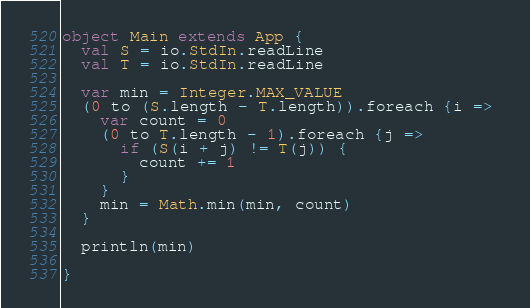Convert code to text. <code><loc_0><loc_0><loc_500><loc_500><_Scala_>
object Main extends App {
  val S = io.StdIn.readLine
  val T = io.StdIn.readLine

  var min = Integer.MAX_VALUE
  (0 to (S.length - T.length)).foreach {i => 
    var count = 0
    (0 to T.length - 1).foreach {j =>
      if (S(i + j) != T(j)) {
        count += 1
      }
    }
    min = Math.min(min, count)
  }

  println(min)

}

</code> 